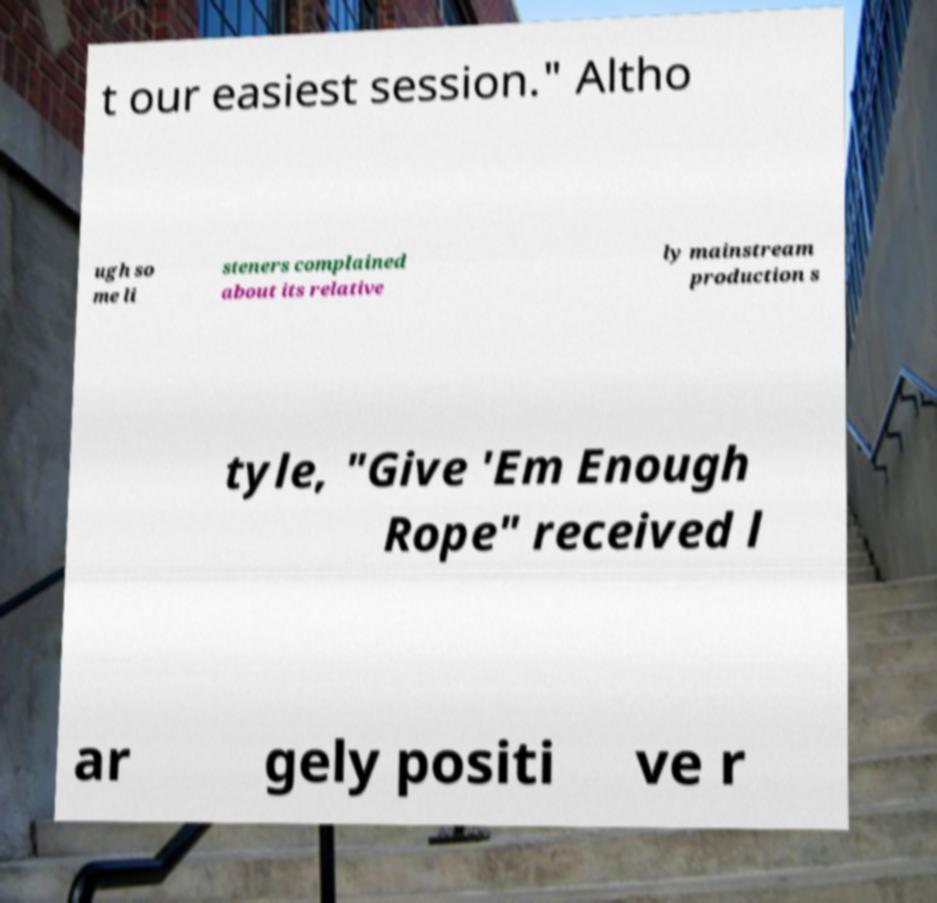Can you accurately transcribe the text from the provided image for me? t our easiest session." Altho ugh so me li steners complained about its relative ly mainstream production s tyle, "Give 'Em Enough Rope" received l ar gely positi ve r 